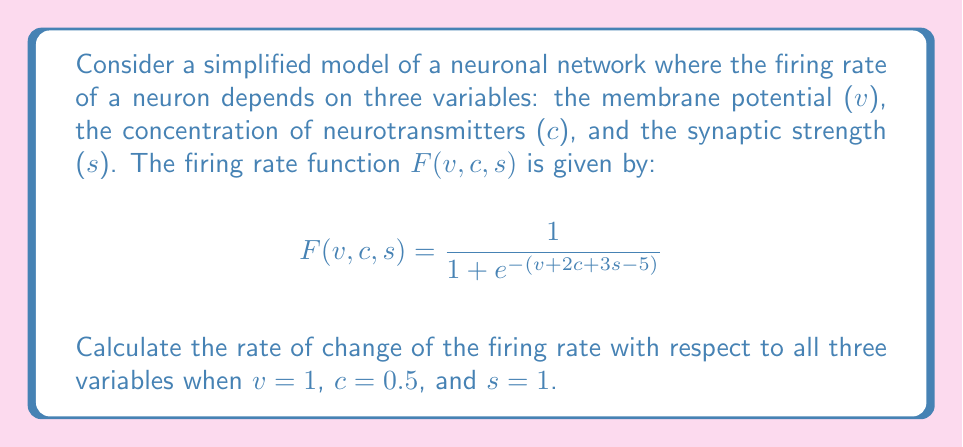Give your solution to this math problem. To solve this problem, we need to use multivariable calculus, specifically partial derivatives and the gradient.

Step 1: Calculate the partial derivatives of F with respect to v, c, and s.

$$\frac{\partial F}{\partial v} = F(1-F)$$
$$\frac{\partial F}{\partial c} = 2F(1-F)$$
$$\frac{\partial F}{\partial s} = 3F(1-F)$$

Step 2: Calculate the value of F at the given point (v = 1, c = 0.5, s = 1).

$$F(1,0.5,1) = \frac{1}{1 + e^{-(1 + 2(0.5) + 3(1) - 5)}} = \frac{1}{1 + e^{-0.5}} \approx 0.6225$$

Step 3: Calculate the values of the partial derivatives at the given point.

$$\frac{\partial F}{\partial v} = 0.6225(1-0.6225) \approx 0.2350$$
$$\frac{\partial F}{\partial c} = 2(0.6225)(1-0.6225) \approx 0.4700$$
$$\frac{\partial F}{\partial s} = 3(0.6225)(1-0.6225) \approx 0.7050$$

Step 4: Express the rate of change as the gradient vector.

$$\nabla F(1,0.5,1) = \left(\frac{\partial F}{\partial v}, \frac{\partial F}{\partial c}, \frac{\partial F}{\partial s}\right) \approx (0.2350, 0.4700, 0.7050)$$

This gradient vector represents the direction and magnitude of the steepest increase in the firing rate at the given point.
Answer: $\nabla F(1,0.5,1) \approx (0.2350, 0.4700, 0.7050)$ 